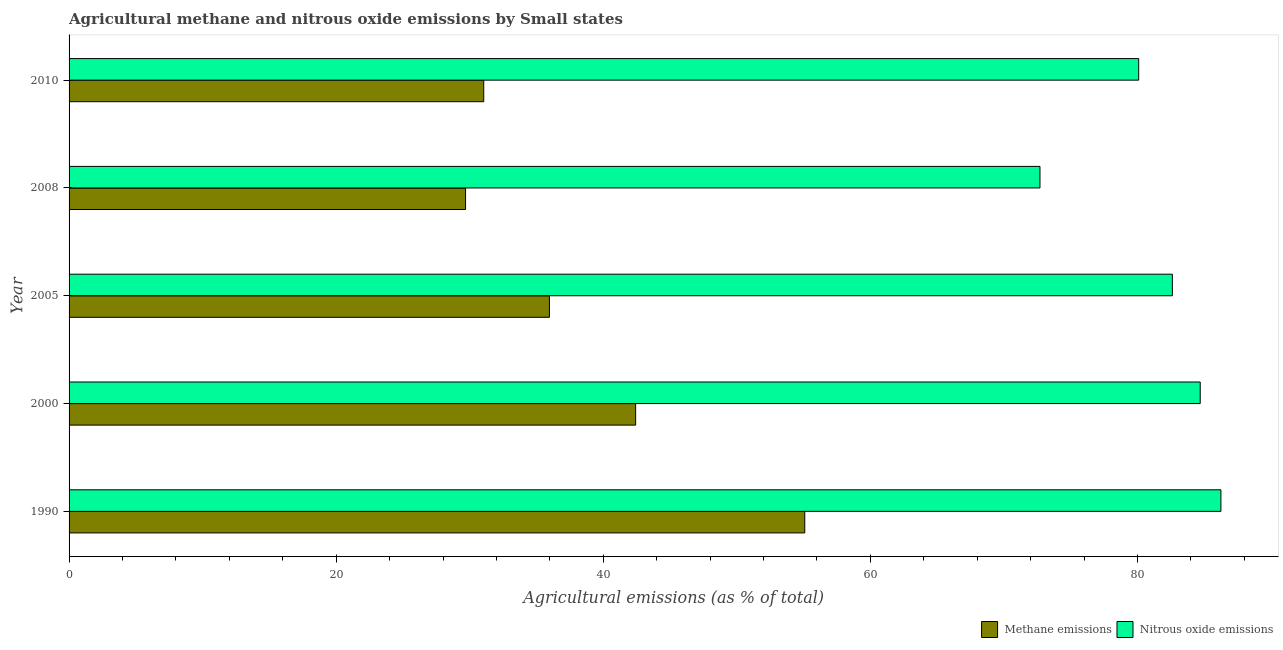Are the number of bars on each tick of the Y-axis equal?
Offer a terse response. Yes. How many bars are there on the 1st tick from the bottom?
Your answer should be very brief. 2. What is the label of the 4th group of bars from the top?
Keep it short and to the point. 2000. In how many cases, is the number of bars for a given year not equal to the number of legend labels?
Offer a very short reply. 0. What is the amount of nitrous oxide emissions in 1990?
Ensure brevity in your answer.  86.24. Across all years, what is the maximum amount of nitrous oxide emissions?
Provide a succinct answer. 86.24. Across all years, what is the minimum amount of methane emissions?
Make the answer very short. 29.69. In which year was the amount of methane emissions maximum?
Offer a very short reply. 1990. What is the total amount of methane emissions in the graph?
Your answer should be very brief. 194.21. What is the difference between the amount of methane emissions in 2000 and that in 2010?
Give a very brief answer. 11.37. What is the difference between the amount of nitrous oxide emissions in 2000 and the amount of methane emissions in 1990?
Give a very brief answer. 29.61. What is the average amount of methane emissions per year?
Provide a succinct answer. 38.84. In the year 2010, what is the difference between the amount of nitrous oxide emissions and amount of methane emissions?
Keep it short and to the point. 49.04. In how many years, is the amount of nitrous oxide emissions greater than 32 %?
Your answer should be very brief. 5. What is the ratio of the amount of methane emissions in 1990 to that in 2005?
Provide a short and direct response. 1.53. Is the amount of methane emissions in 2000 less than that in 2010?
Your answer should be compact. No. Is the difference between the amount of methane emissions in 2000 and 2005 greater than the difference between the amount of nitrous oxide emissions in 2000 and 2005?
Offer a very short reply. Yes. What is the difference between the highest and the second highest amount of methane emissions?
Offer a very short reply. 12.66. What is the difference between the highest and the lowest amount of nitrous oxide emissions?
Keep it short and to the point. 13.55. Is the sum of the amount of nitrous oxide emissions in 1990 and 2008 greater than the maximum amount of methane emissions across all years?
Provide a short and direct response. Yes. What does the 2nd bar from the top in 2000 represents?
Ensure brevity in your answer.  Methane emissions. What does the 2nd bar from the bottom in 2005 represents?
Offer a terse response. Nitrous oxide emissions. Are the values on the major ticks of X-axis written in scientific E-notation?
Your answer should be very brief. No. What is the title of the graph?
Your response must be concise. Agricultural methane and nitrous oxide emissions by Small states. What is the label or title of the X-axis?
Your answer should be compact. Agricultural emissions (as % of total). What is the Agricultural emissions (as % of total) of Methane emissions in 1990?
Provide a succinct answer. 55.09. What is the Agricultural emissions (as % of total) in Nitrous oxide emissions in 1990?
Keep it short and to the point. 86.24. What is the Agricultural emissions (as % of total) of Methane emissions in 2000?
Offer a terse response. 42.42. What is the Agricultural emissions (as % of total) of Nitrous oxide emissions in 2000?
Ensure brevity in your answer.  84.69. What is the Agricultural emissions (as % of total) in Methane emissions in 2005?
Offer a terse response. 35.97. What is the Agricultural emissions (as % of total) of Nitrous oxide emissions in 2005?
Your response must be concise. 82.61. What is the Agricultural emissions (as % of total) in Methane emissions in 2008?
Offer a very short reply. 29.69. What is the Agricultural emissions (as % of total) in Nitrous oxide emissions in 2008?
Your response must be concise. 72.7. What is the Agricultural emissions (as % of total) of Methane emissions in 2010?
Provide a succinct answer. 31.05. What is the Agricultural emissions (as % of total) of Nitrous oxide emissions in 2010?
Provide a succinct answer. 80.09. Across all years, what is the maximum Agricultural emissions (as % of total) of Methane emissions?
Your answer should be compact. 55.09. Across all years, what is the maximum Agricultural emissions (as % of total) in Nitrous oxide emissions?
Keep it short and to the point. 86.24. Across all years, what is the minimum Agricultural emissions (as % of total) of Methane emissions?
Your answer should be compact. 29.69. Across all years, what is the minimum Agricultural emissions (as % of total) of Nitrous oxide emissions?
Your response must be concise. 72.7. What is the total Agricultural emissions (as % of total) in Methane emissions in the graph?
Offer a very short reply. 194.21. What is the total Agricultural emissions (as % of total) in Nitrous oxide emissions in the graph?
Offer a terse response. 406.33. What is the difference between the Agricultural emissions (as % of total) of Methane emissions in 1990 and that in 2000?
Your answer should be compact. 12.66. What is the difference between the Agricultural emissions (as % of total) in Nitrous oxide emissions in 1990 and that in 2000?
Your response must be concise. 1.55. What is the difference between the Agricultural emissions (as % of total) in Methane emissions in 1990 and that in 2005?
Your response must be concise. 19.12. What is the difference between the Agricultural emissions (as % of total) of Nitrous oxide emissions in 1990 and that in 2005?
Provide a short and direct response. 3.64. What is the difference between the Agricultural emissions (as % of total) of Methane emissions in 1990 and that in 2008?
Your answer should be compact. 25.4. What is the difference between the Agricultural emissions (as % of total) in Nitrous oxide emissions in 1990 and that in 2008?
Offer a very short reply. 13.55. What is the difference between the Agricultural emissions (as % of total) in Methane emissions in 1990 and that in 2010?
Offer a terse response. 24.04. What is the difference between the Agricultural emissions (as % of total) in Nitrous oxide emissions in 1990 and that in 2010?
Give a very brief answer. 6.16. What is the difference between the Agricultural emissions (as % of total) in Methane emissions in 2000 and that in 2005?
Your answer should be compact. 6.45. What is the difference between the Agricultural emissions (as % of total) of Nitrous oxide emissions in 2000 and that in 2005?
Your answer should be compact. 2.09. What is the difference between the Agricultural emissions (as % of total) of Methane emissions in 2000 and that in 2008?
Offer a terse response. 12.73. What is the difference between the Agricultural emissions (as % of total) of Nitrous oxide emissions in 2000 and that in 2008?
Ensure brevity in your answer.  12. What is the difference between the Agricultural emissions (as % of total) in Methane emissions in 2000 and that in 2010?
Your response must be concise. 11.37. What is the difference between the Agricultural emissions (as % of total) in Nitrous oxide emissions in 2000 and that in 2010?
Offer a terse response. 4.61. What is the difference between the Agricultural emissions (as % of total) in Methane emissions in 2005 and that in 2008?
Your answer should be very brief. 6.28. What is the difference between the Agricultural emissions (as % of total) of Nitrous oxide emissions in 2005 and that in 2008?
Offer a terse response. 9.91. What is the difference between the Agricultural emissions (as % of total) in Methane emissions in 2005 and that in 2010?
Your response must be concise. 4.92. What is the difference between the Agricultural emissions (as % of total) in Nitrous oxide emissions in 2005 and that in 2010?
Your response must be concise. 2.52. What is the difference between the Agricultural emissions (as % of total) of Methane emissions in 2008 and that in 2010?
Make the answer very short. -1.36. What is the difference between the Agricultural emissions (as % of total) in Nitrous oxide emissions in 2008 and that in 2010?
Offer a very short reply. -7.39. What is the difference between the Agricultural emissions (as % of total) in Methane emissions in 1990 and the Agricultural emissions (as % of total) in Nitrous oxide emissions in 2000?
Keep it short and to the point. -29.61. What is the difference between the Agricultural emissions (as % of total) of Methane emissions in 1990 and the Agricultural emissions (as % of total) of Nitrous oxide emissions in 2005?
Your response must be concise. -27.52. What is the difference between the Agricultural emissions (as % of total) of Methane emissions in 1990 and the Agricultural emissions (as % of total) of Nitrous oxide emissions in 2008?
Ensure brevity in your answer.  -17.61. What is the difference between the Agricultural emissions (as % of total) of Methane emissions in 1990 and the Agricultural emissions (as % of total) of Nitrous oxide emissions in 2010?
Provide a short and direct response. -25. What is the difference between the Agricultural emissions (as % of total) of Methane emissions in 2000 and the Agricultural emissions (as % of total) of Nitrous oxide emissions in 2005?
Offer a terse response. -40.19. What is the difference between the Agricultural emissions (as % of total) of Methane emissions in 2000 and the Agricultural emissions (as % of total) of Nitrous oxide emissions in 2008?
Offer a terse response. -30.27. What is the difference between the Agricultural emissions (as % of total) in Methane emissions in 2000 and the Agricultural emissions (as % of total) in Nitrous oxide emissions in 2010?
Offer a very short reply. -37.67. What is the difference between the Agricultural emissions (as % of total) in Methane emissions in 2005 and the Agricultural emissions (as % of total) in Nitrous oxide emissions in 2008?
Make the answer very short. -36.73. What is the difference between the Agricultural emissions (as % of total) of Methane emissions in 2005 and the Agricultural emissions (as % of total) of Nitrous oxide emissions in 2010?
Make the answer very short. -44.12. What is the difference between the Agricultural emissions (as % of total) of Methane emissions in 2008 and the Agricultural emissions (as % of total) of Nitrous oxide emissions in 2010?
Offer a terse response. -50.4. What is the average Agricultural emissions (as % of total) in Methane emissions per year?
Your response must be concise. 38.84. What is the average Agricultural emissions (as % of total) of Nitrous oxide emissions per year?
Ensure brevity in your answer.  81.27. In the year 1990, what is the difference between the Agricultural emissions (as % of total) in Methane emissions and Agricultural emissions (as % of total) in Nitrous oxide emissions?
Offer a very short reply. -31.16. In the year 2000, what is the difference between the Agricultural emissions (as % of total) of Methane emissions and Agricultural emissions (as % of total) of Nitrous oxide emissions?
Your answer should be compact. -42.27. In the year 2005, what is the difference between the Agricultural emissions (as % of total) in Methane emissions and Agricultural emissions (as % of total) in Nitrous oxide emissions?
Your answer should be compact. -46.64. In the year 2008, what is the difference between the Agricultural emissions (as % of total) in Methane emissions and Agricultural emissions (as % of total) in Nitrous oxide emissions?
Your answer should be very brief. -43.01. In the year 2010, what is the difference between the Agricultural emissions (as % of total) in Methane emissions and Agricultural emissions (as % of total) in Nitrous oxide emissions?
Your answer should be compact. -49.04. What is the ratio of the Agricultural emissions (as % of total) of Methane emissions in 1990 to that in 2000?
Provide a short and direct response. 1.3. What is the ratio of the Agricultural emissions (as % of total) in Nitrous oxide emissions in 1990 to that in 2000?
Your response must be concise. 1.02. What is the ratio of the Agricultural emissions (as % of total) of Methane emissions in 1990 to that in 2005?
Ensure brevity in your answer.  1.53. What is the ratio of the Agricultural emissions (as % of total) of Nitrous oxide emissions in 1990 to that in 2005?
Offer a terse response. 1.04. What is the ratio of the Agricultural emissions (as % of total) of Methane emissions in 1990 to that in 2008?
Provide a succinct answer. 1.86. What is the ratio of the Agricultural emissions (as % of total) in Nitrous oxide emissions in 1990 to that in 2008?
Offer a terse response. 1.19. What is the ratio of the Agricultural emissions (as % of total) in Methane emissions in 1990 to that in 2010?
Ensure brevity in your answer.  1.77. What is the ratio of the Agricultural emissions (as % of total) of Nitrous oxide emissions in 1990 to that in 2010?
Provide a succinct answer. 1.08. What is the ratio of the Agricultural emissions (as % of total) in Methane emissions in 2000 to that in 2005?
Keep it short and to the point. 1.18. What is the ratio of the Agricultural emissions (as % of total) of Nitrous oxide emissions in 2000 to that in 2005?
Provide a short and direct response. 1.03. What is the ratio of the Agricultural emissions (as % of total) of Methane emissions in 2000 to that in 2008?
Provide a short and direct response. 1.43. What is the ratio of the Agricultural emissions (as % of total) of Nitrous oxide emissions in 2000 to that in 2008?
Offer a very short reply. 1.17. What is the ratio of the Agricultural emissions (as % of total) of Methane emissions in 2000 to that in 2010?
Provide a short and direct response. 1.37. What is the ratio of the Agricultural emissions (as % of total) in Nitrous oxide emissions in 2000 to that in 2010?
Provide a succinct answer. 1.06. What is the ratio of the Agricultural emissions (as % of total) of Methane emissions in 2005 to that in 2008?
Provide a short and direct response. 1.21. What is the ratio of the Agricultural emissions (as % of total) in Nitrous oxide emissions in 2005 to that in 2008?
Your response must be concise. 1.14. What is the ratio of the Agricultural emissions (as % of total) of Methane emissions in 2005 to that in 2010?
Ensure brevity in your answer.  1.16. What is the ratio of the Agricultural emissions (as % of total) in Nitrous oxide emissions in 2005 to that in 2010?
Ensure brevity in your answer.  1.03. What is the ratio of the Agricultural emissions (as % of total) in Methane emissions in 2008 to that in 2010?
Offer a very short reply. 0.96. What is the ratio of the Agricultural emissions (as % of total) in Nitrous oxide emissions in 2008 to that in 2010?
Your answer should be very brief. 0.91. What is the difference between the highest and the second highest Agricultural emissions (as % of total) of Methane emissions?
Your response must be concise. 12.66. What is the difference between the highest and the second highest Agricultural emissions (as % of total) of Nitrous oxide emissions?
Ensure brevity in your answer.  1.55. What is the difference between the highest and the lowest Agricultural emissions (as % of total) in Methane emissions?
Your answer should be very brief. 25.4. What is the difference between the highest and the lowest Agricultural emissions (as % of total) of Nitrous oxide emissions?
Provide a succinct answer. 13.55. 